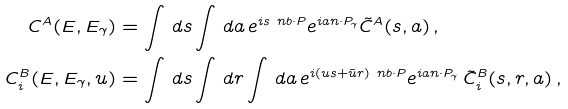<formula> <loc_0><loc_0><loc_500><loc_500>C ^ { A } ( E , E _ { \gamma } ) & = \int \, d s \int \, d a \, e ^ { i s \ n b \cdot P } e ^ { i a n \cdot P _ { \gamma } } \tilde { C } ^ { A } ( s , a ) \, , \\ C _ { i } ^ { B } ( E , E _ { \gamma } , u ) & = \int \, d s \int \, d r \int \, d a \, e ^ { i ( u s + \bar { u } r ) \ n b \cdot P } e ^ { i a n \cdot P _ { \gamma } } \, \tilde { C } _ { i } ^ { B } ( s , r , a ) \, ,</formula> 